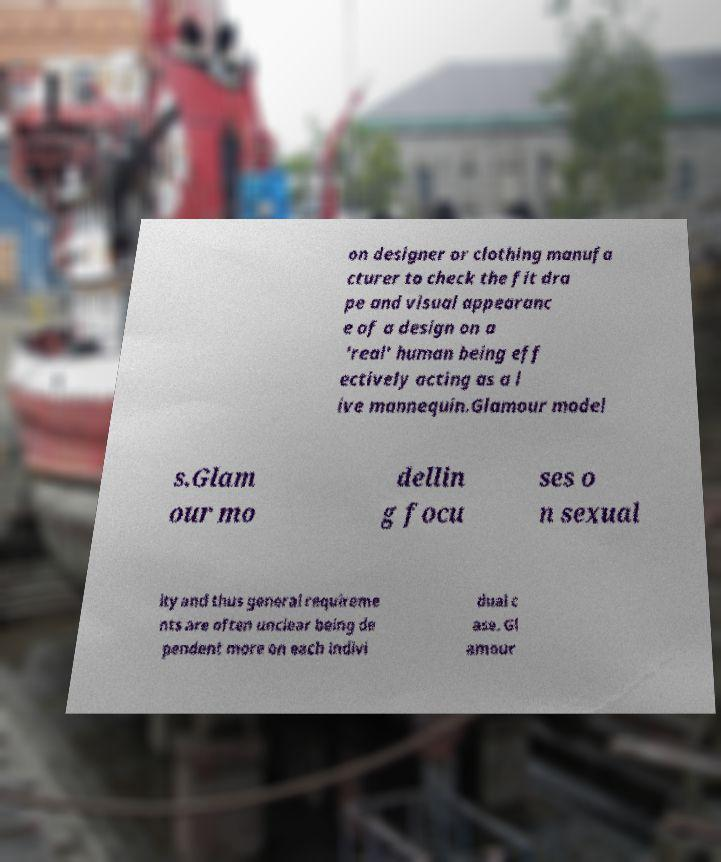For documentation purposes, I need the text within this image transcribed. Could you provide that? on designer or clothing manufa cturer to check the fit dra pe and visual appearanc e of a design on a 'real' human being eff ectively acting as a l ive mannequin.Glamour model s.Glam our mo dellin g focu ses o n sexual ity and thus general requireme nts are often unclear being de pendent more on each indivi dual c ase. Gl amour 